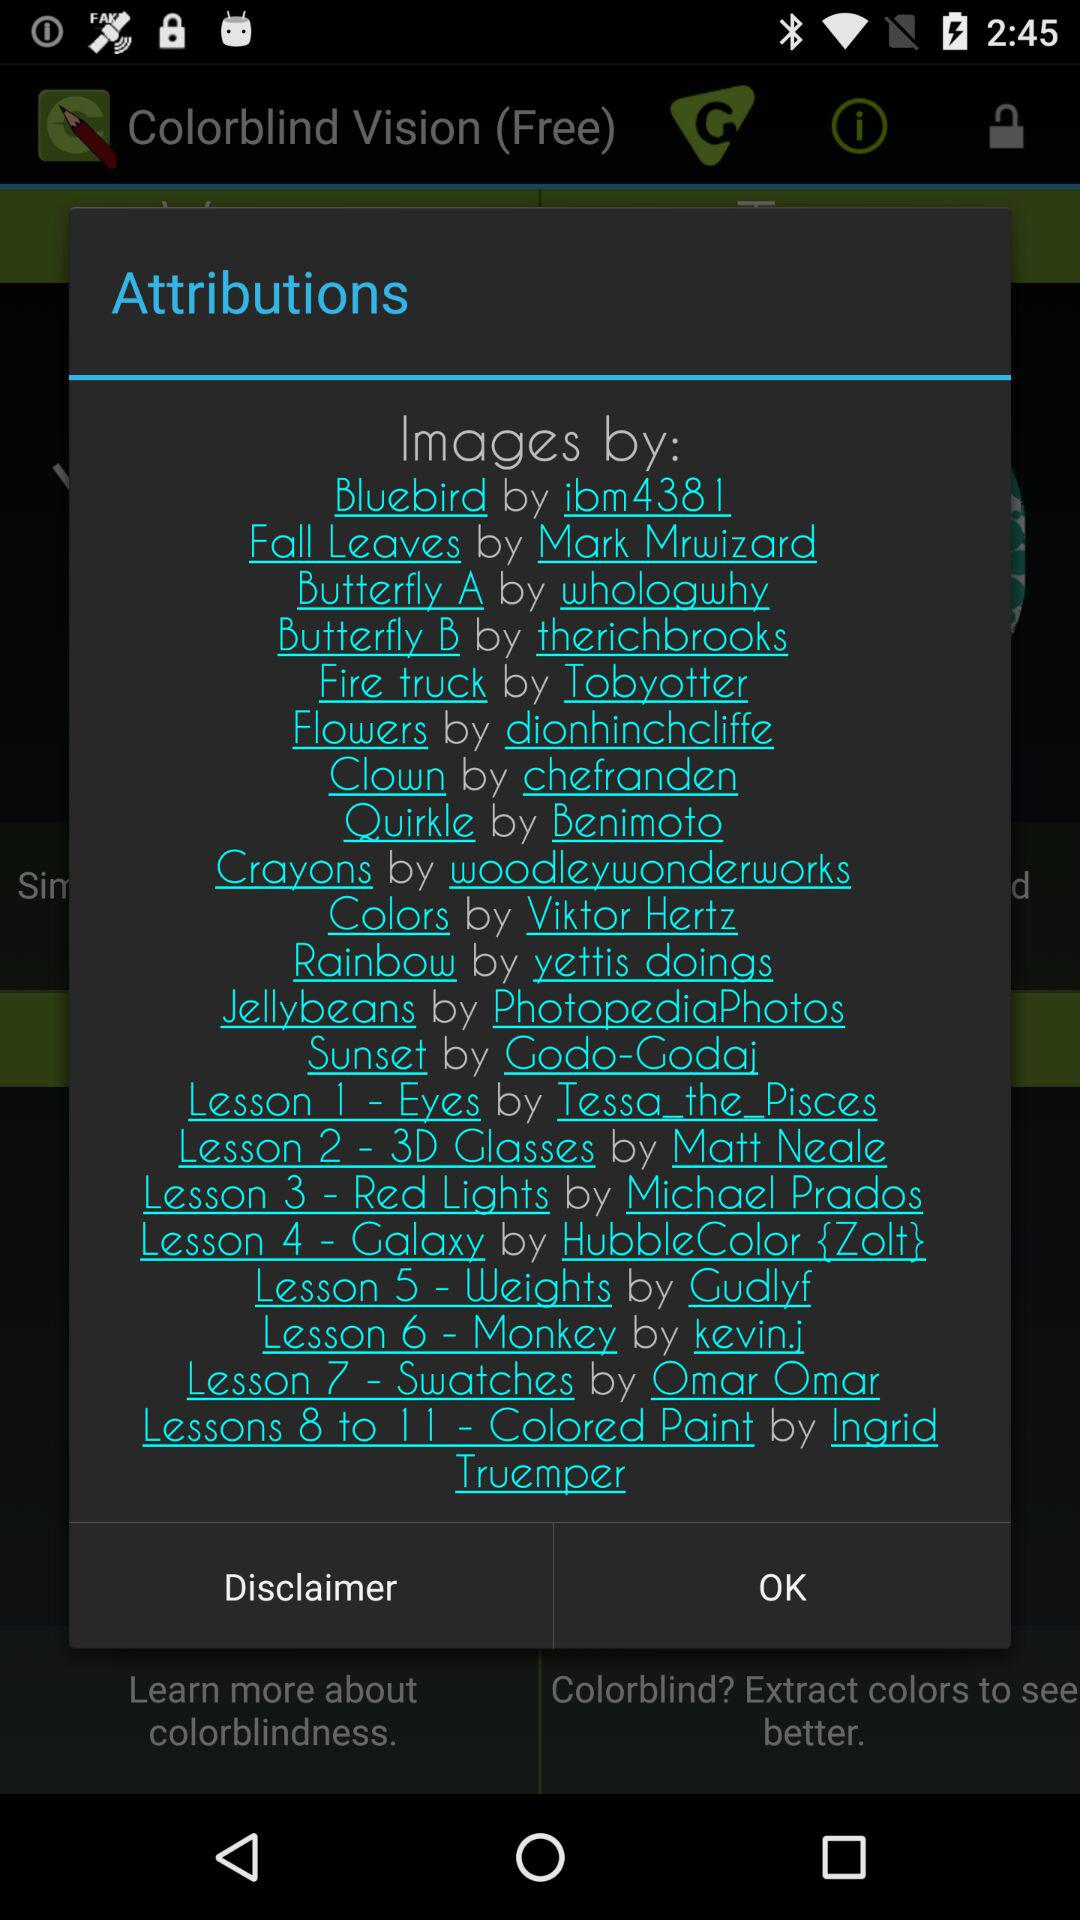Who made the image of "Fall Leaves"? The image of "Fall Leaves" was made by Mark Mrwizard. 